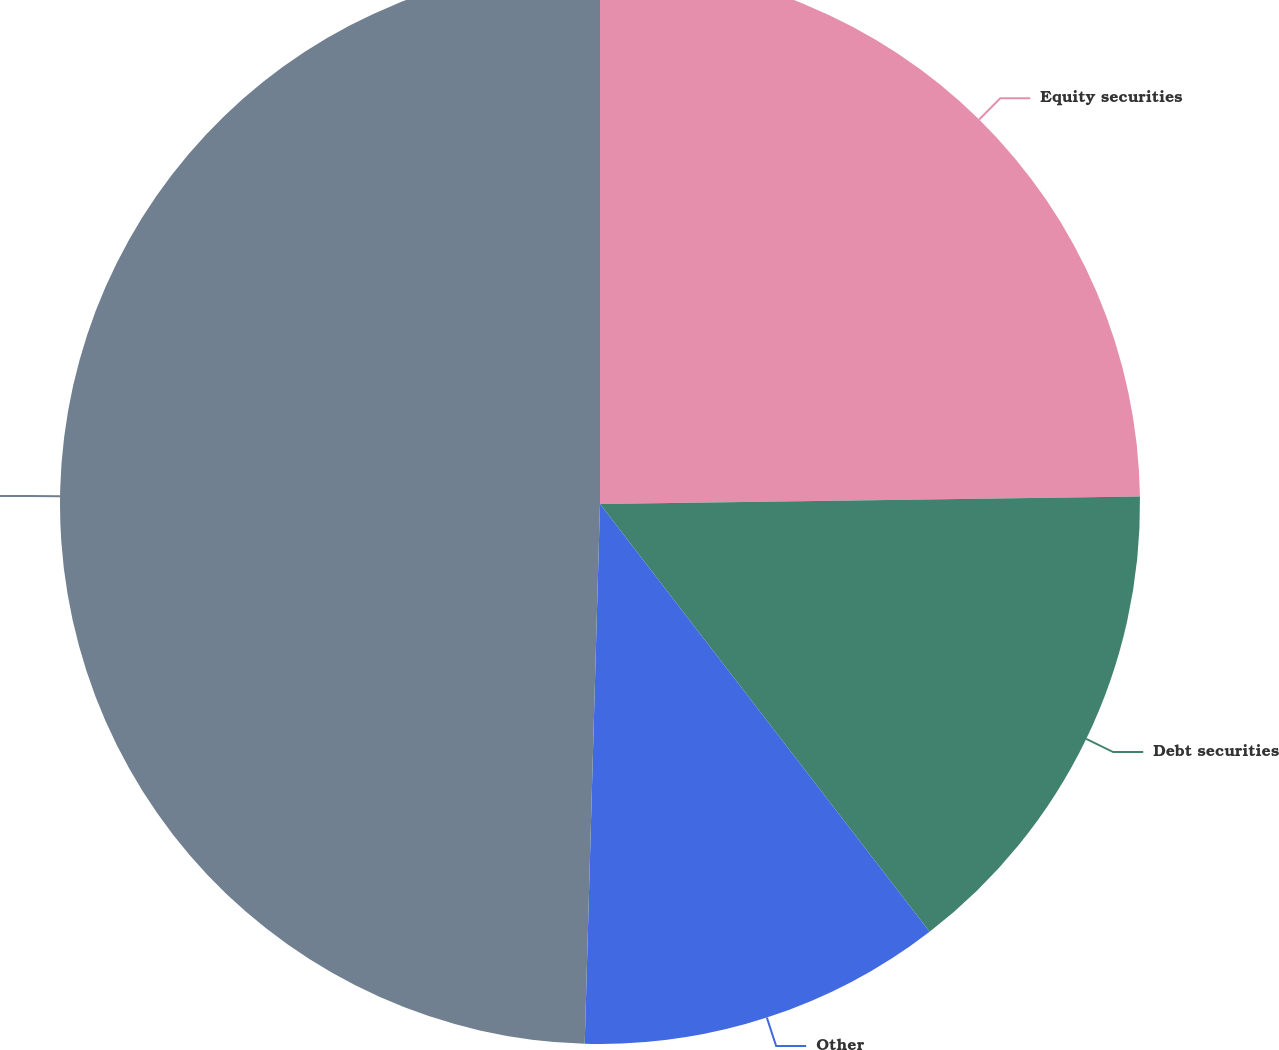Convert chart to OTSL. <chart><loc_0><loc_0><loc_500><loc_500><pie_chart><fcel>Equity securities<fcel>Debt securities<fcel>Other<fcel>Total<nl><fcel>24.78%<fcel>14.77%<fcel>10.9%<fcel>49.55%<nl></chart> 